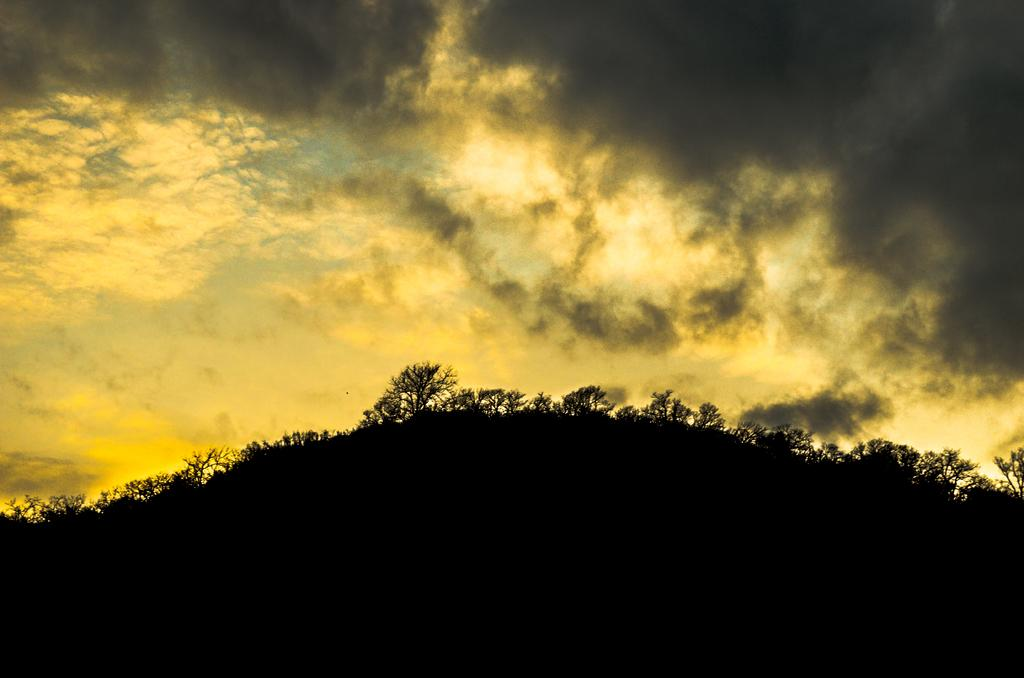What geographical feature is the main subject of the image? There is a mountain in the image. What can be seen on the mountain? There are trees on the mountain. What is visible at the top of the image? The sky is visible at the top of the image. What is the weather like in the image? The sky is cloudy, and the colors yellow and black are present, which might suggest a stormy or overcast condition. What type of church can be seen at the top of the mountain in the image? There is no church present in the image; it features a mountain with trees and a cloudy sky. What type of motion can be observed in the image? There is no motion visible in the image; it is a static representation of a mountain, trees, and the sky. 